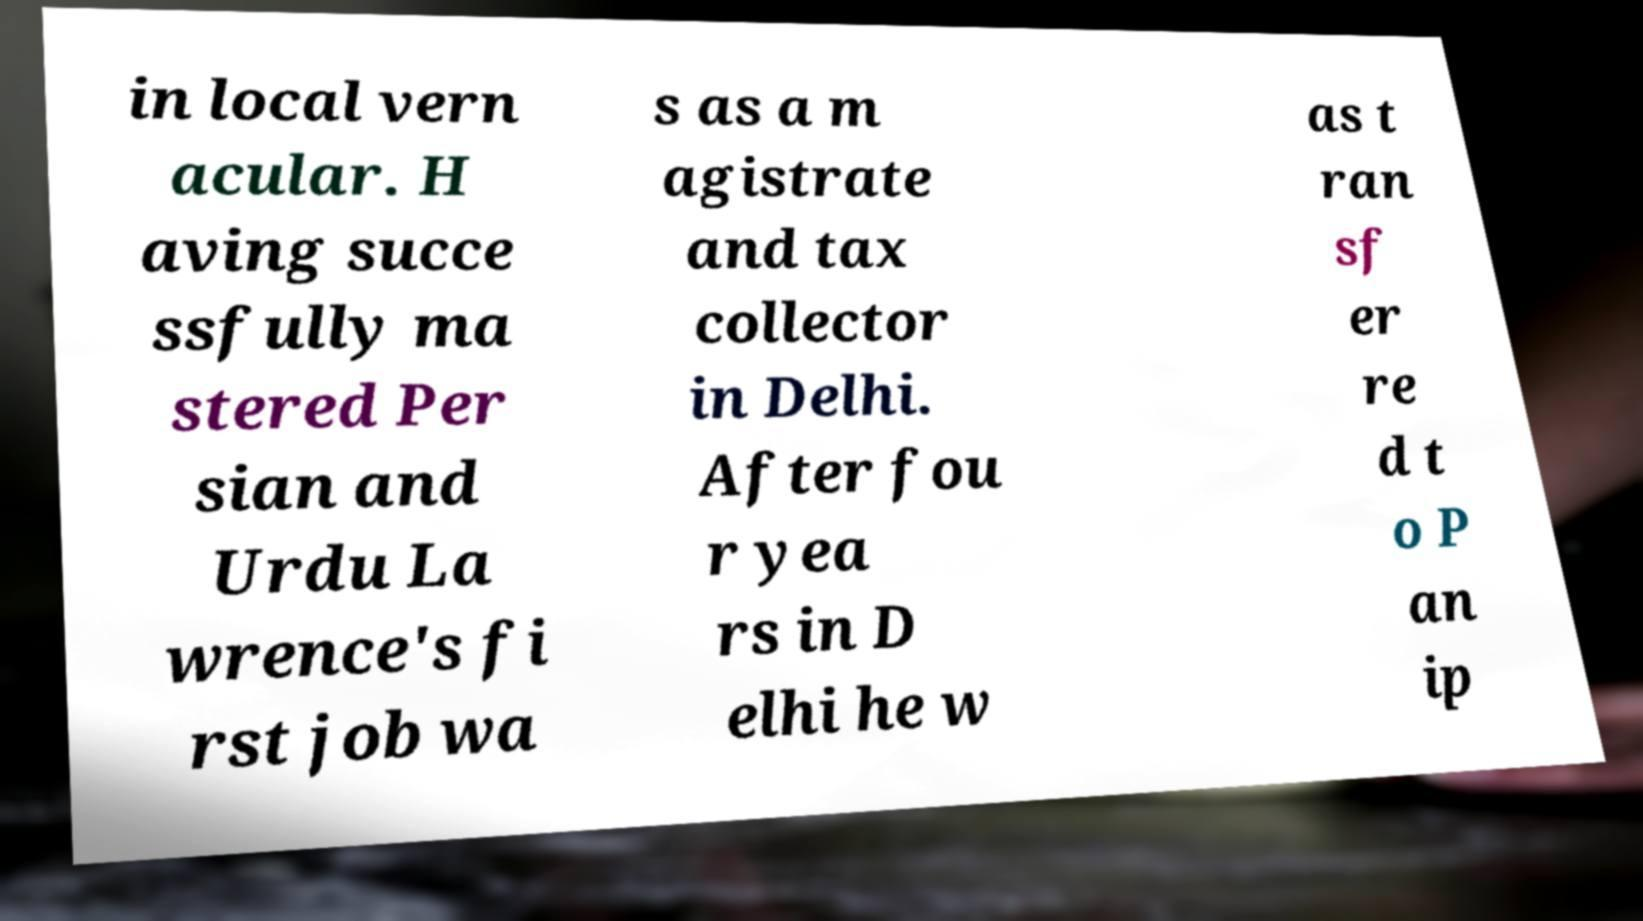There's text embedded in this image that I need extracted. Can you transcribe it verbatim? in local vern acular. H aving succe ssfully ma stered Per sian and Urdu La wrence's fi rst job wa s as a m agistrate and tax collector in Delhi. After fou r yea rs in D elhi he w as t ran sf er re d t o P an ip 